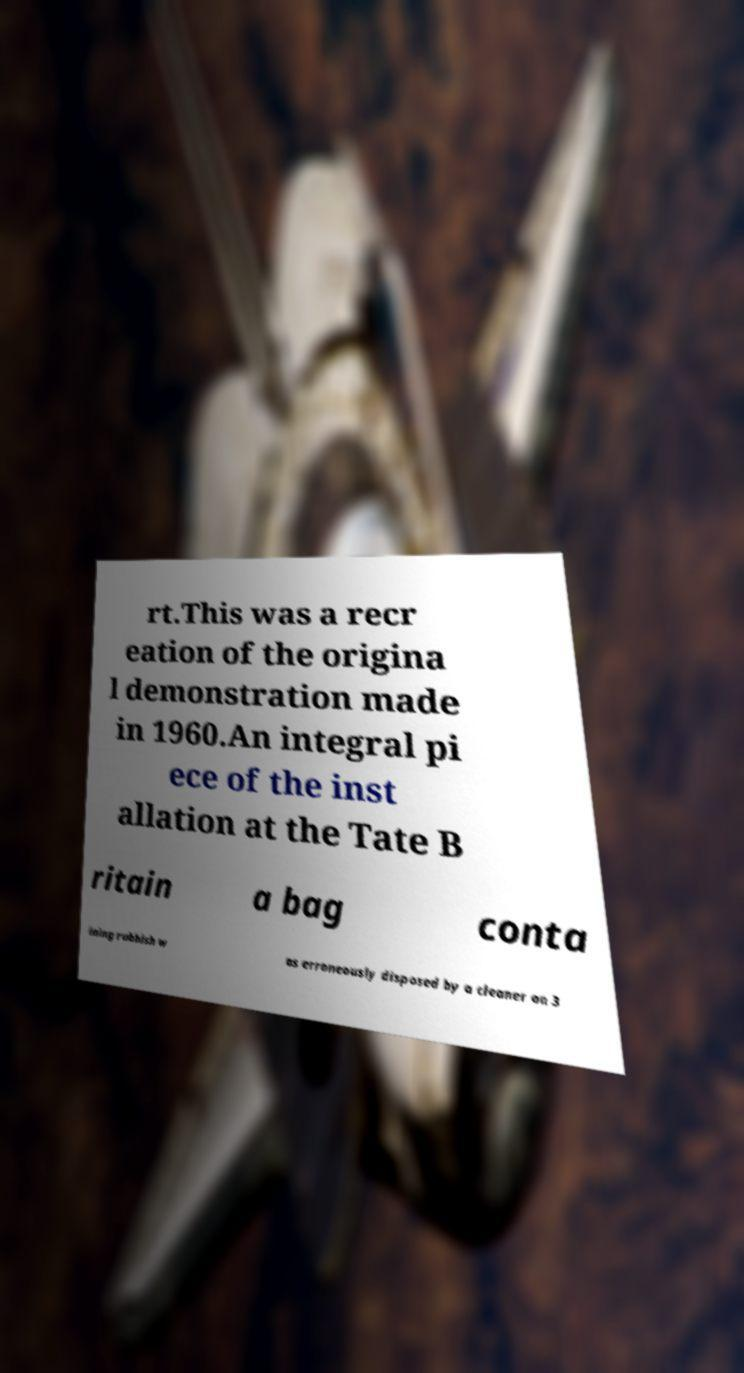Can you read and provide the text displayed in the image?This photo seems to have some interesting text. Can you extract and type it out for me? rt.This was a recr eation of the origina l demonstration made in 1960.An integral pi ece of the inst allation at the Tate B ritain a bag conta ining rubbish w as erroneously disposed by a cleaner on 3 